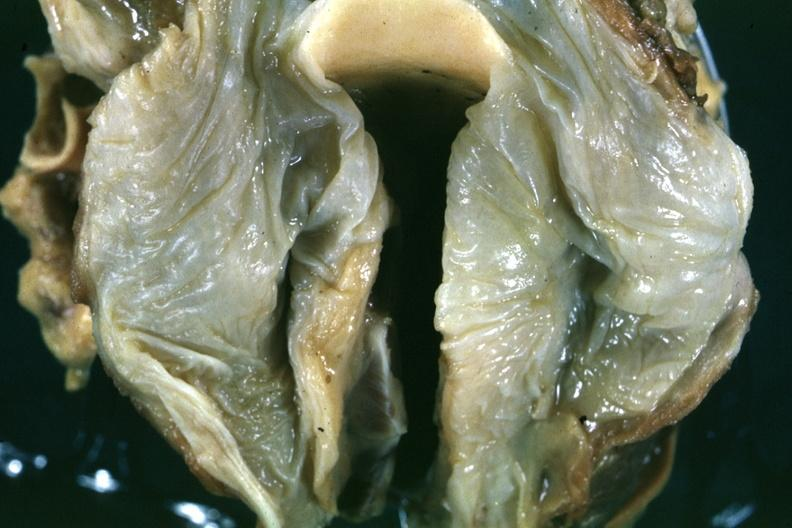what does this image show?
Answer the question using a single word or phrase. Fixed tissue quite good example of hypopharyngeal edema larynx is opened slide is a close-up in natural color of the edematous mucosal membrane 